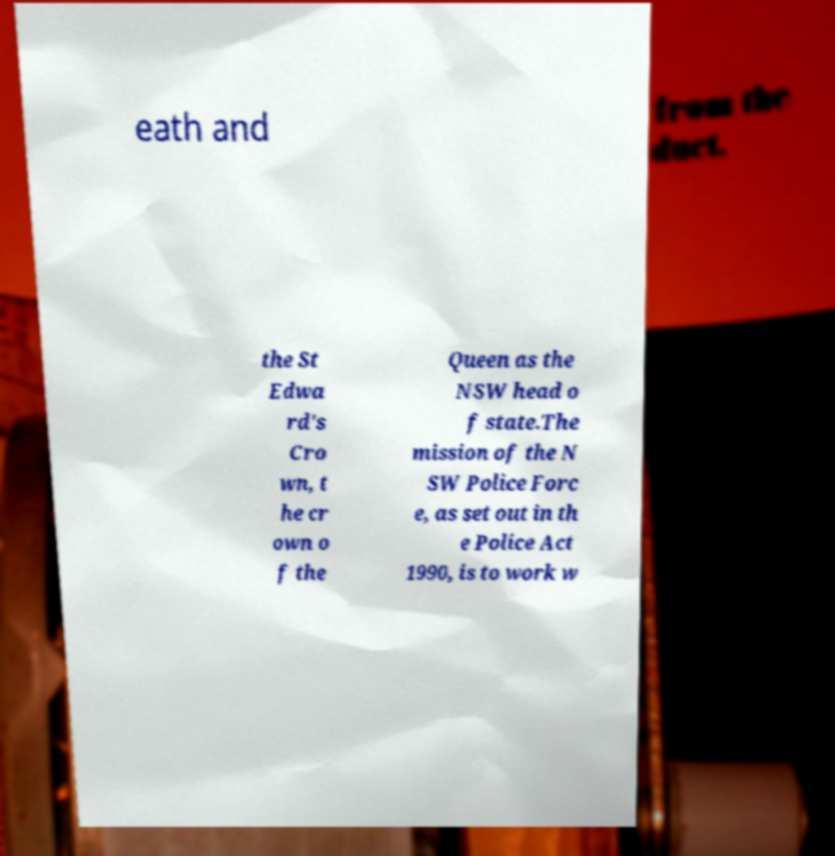What messages or text are displayed in this image? I need them in a readable, typed format. eath and the St Edwa rd's Cro wn, t he cr own o f the Queen as the NSW head o f state.The mission of the N SW Police Forc e, as set out in th e Police Act 1990, is to work w 